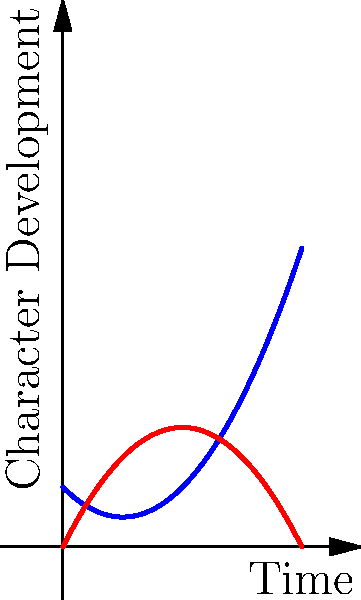In the given line graph representing character development arcs, which character shows a more dynamic change throughout the story, and what narrative technique does this suggest? To analyze the character development arcs:

1. Observe the curves:
   - Character A (blue): starts high, dips, then rises sharply
   - Character B (red): starts low, rises, then plateaus

2. Interpret the shapes:
   - Character A's U-shaped curve suggests a fall and redemption arc
   - Character B's inverted U-shape indicates growth followed by stability

3. Compare dynamism:
   - Character A shows more dramatic change (larger vertical movement)
   - Character B's change is more gradual and settles

4. Consider narrative implications:
   - Character A's arc suggests a more transformative journey
   - This implies use of the "Hero's Journey" or similar dramatic structure

5. Conclude:
   - Character A demonstrates more dynamic change
   - This suggests the use of a classic character transformation narrative technique
Answer: Character A; Hero's Journey 